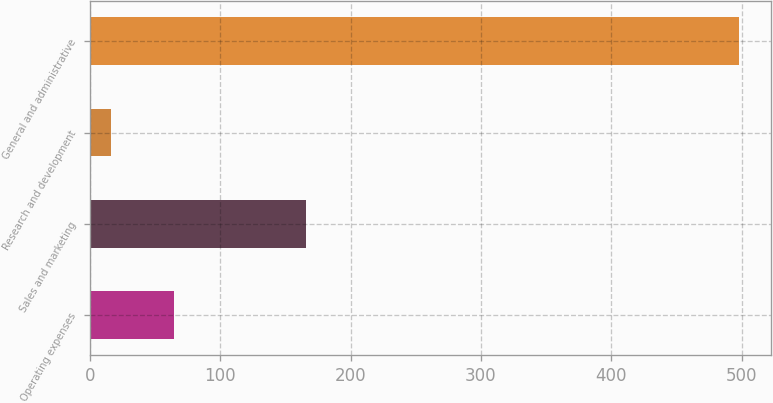Convert chart. <chart><loc_0><loc_0><loc_500><loc_500><bar_chart><fcel>Operating expenses<fcel>Sales and marketing<fcel>Research and development<fcel>General and administrative<nl><fcel>64.2<fcel>166<fcel>16<fcel>498<nl></chart> 